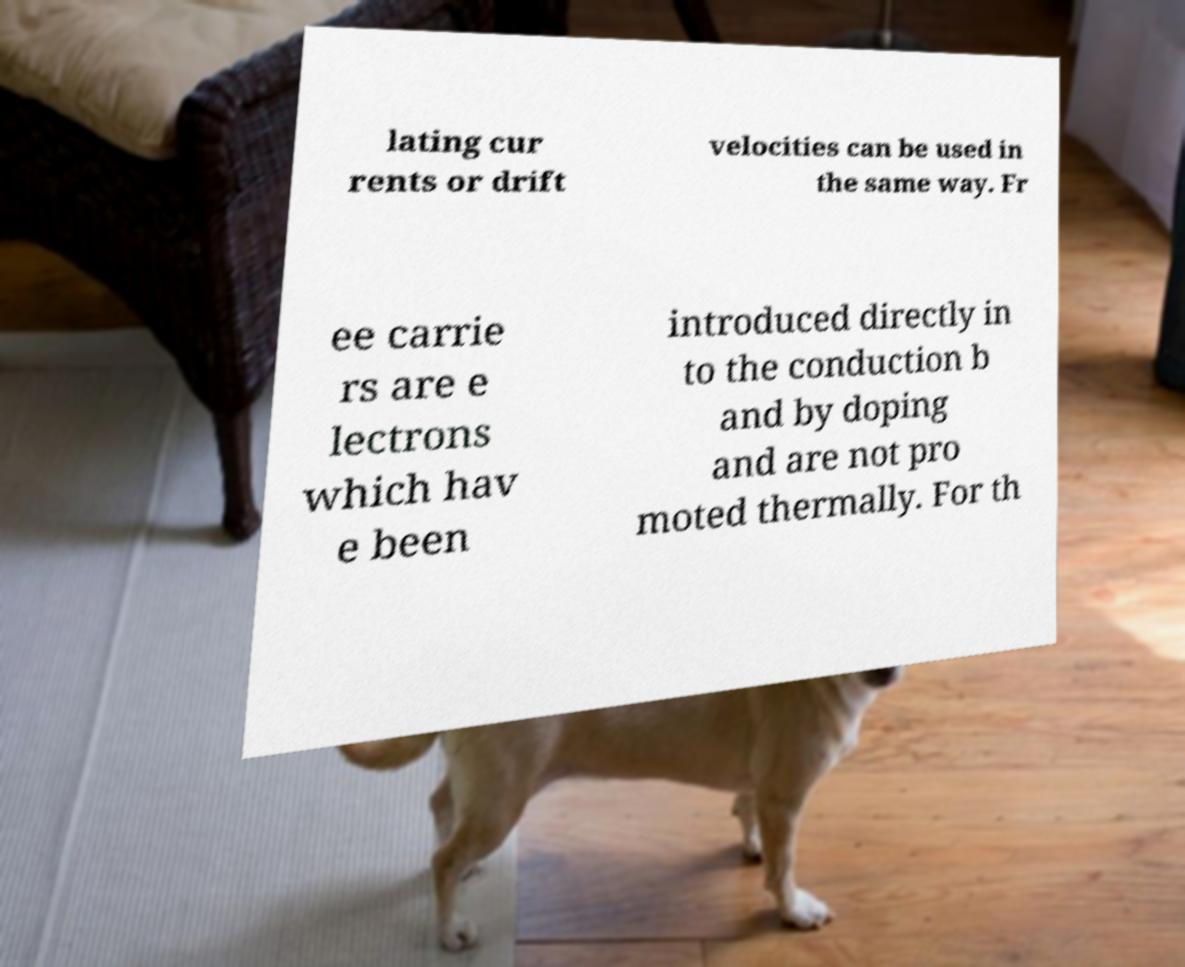For documentation purposes, I need the text within this image transcribed. Could you provide that? lating cur rents or drift velocities can be used in the same way. Fr ee carrie rs are e lectrons which hav e been introduced directly in to the conduction b and by doping and are not pro moted thermally. For th 